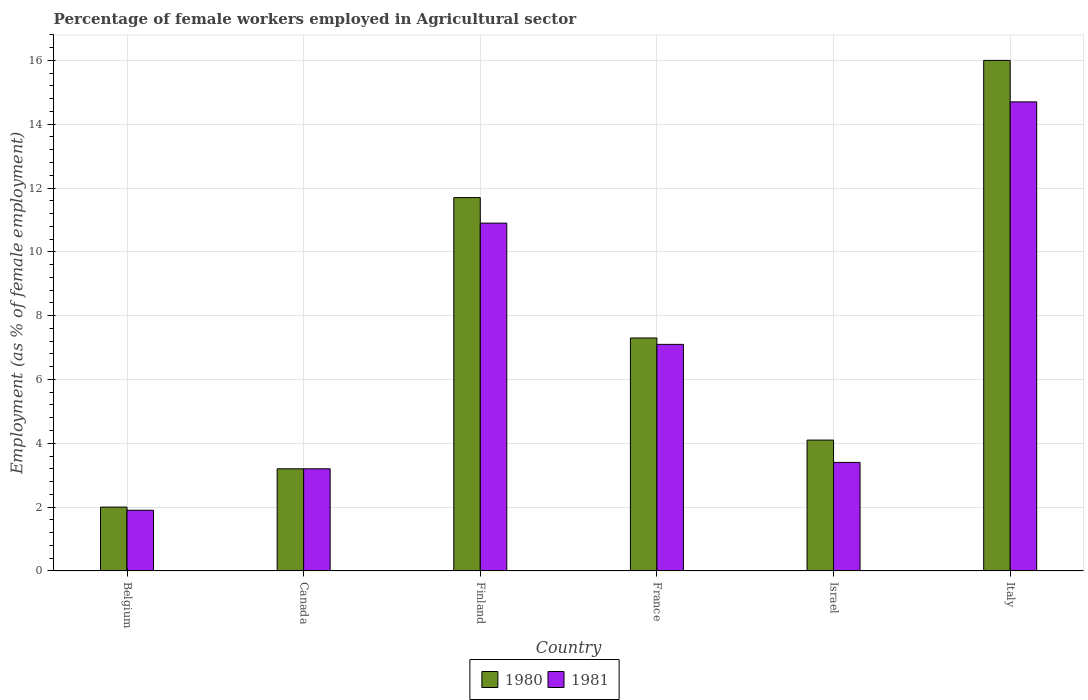How many different coloured bars are there?
Make the answer very short. 2. How many groups of bars are there?
Ensure brevity in your answer.  6. Are the number of bars on each tick of the X-axis equal?
Ensure brevity in your answer.  Yes. How many bars are there on the 4th tick from the right?
Provide a succinct answer. 2. What is the percentage of females employed in Agricultural sector in 1980 in Israel?
Make the answer very short. 4.1. Across all countries, what is the maximum percentage of females employed in Agricultural sector in 1981?
Offer a very short reply. 14.7. Across all countries, what is the minimum percentage of females employed in Agricultural sector in 1980?
Offer a terse response. 2. In which country was the percentage of females employed in Agricultural sector in 1980 minimum?
Provide a succinct answer. Belgium. What is the total percentage of females employed in Agricultural sector in 1981 in the graph?
Give a very brief answer. 41.2. What is the difference between the percentage of females employed in Agricultural sector in 1980 in Finland and that in France?
Offer a terse response. 4.4. What is the difference between the percentage of females employed in Agricultural sector in 1980 in France and the percentage of females employed in Agricultural sector in 1981 in Italy?
Provide a short and direct response. -7.4. What is the average percentage of females employed in Agricultural sector in 1981 per country?
Make the answer very short. 6.87. What is the difference between the percentage of females employed in Agricultural sector of/in 1980 and percentage of females employed in Agricultural sector of/in 1981 in Finland?
Your response must be concise. 0.8. What is the ratio of the percentage of females employed in Agricultural sector in 1980 in Canada to that in Israel?
Provide a short and direct response. 0.78. What is the difference between the highest and the second highest percentage of females employed in Agricultural sector in 1981?
Make the answer very short. -3.8. What is the difference between the highest and the lowest percentage of females employed in Agricultural sector in 1980?
Provide a succinct answer. 14. Is the sum of the percentage of females employed in Agricultural sector in 1981 in Canada and Israel greater than the maximum percentage of females employed in Agricultural sector in 1980 across all countries?
Provide a succinct answer. No. Are all the bars in the graph horizontal?
Your answer should be very brief. No. What is the difference between two consecutive major ticks on the Y-axis?
Your response must be concise. 2. Does the graph contain grids?
Offer a very short reply. Yes. How are the legend labels stacked?
Your response must be concise. Horizontal. What is the title of the graph?
Your answer should be very brief. Percentage of female workers employed in Agricultural sector. What is the label or title of the X-axis?
Provide a short and direct response. Country. What is the label or title of the Y-axis?
Give a very brief answer. Employment (as % of female employment). What is the Employment (as % of female employment) in 1980 in Belgium?
Offer a very short reply. 2. What is the Employment (as % of female employment) of 1981 in Belgium?
Keep it short and to the point. 1.9. What is the Employment (as % of female employment) in 1980 in Canada?
Make the answer very short. 3.2. What is the Employment (as % of female employment) of 1981 in Canada?
Your response must be concise. 3.2. What is the Employment (as % of female employment) in 1980 in Finland?
Offer a very short reply. 11.7. What is the Employment (as % of female employment) in 1981 in Finland?
Your answer should be compact. 10.9. What is the Employment (as % of female employment) in 1980 in France?
Your answer should be compact. 7.3. What is the Employment (as % of female employment) in 1981 in France?
Give a very brief answer. 7.1. What is the Employment (as % of female employment) in 1980 in Israel?
Ensure brevity in your answer.  4.1. What is the Employment (as % of female employment) of 1981 in Israel?
Make the answer very short. 3.4. What is the Employment (as % of female employment) in 1980 in Italy?
Your answer should be very brief. 16. What is the Employment (as % of female employment) in 1981 in Italy?
Your response must be concise. 14.7. Across all countries, what is the maximum Employment (as % of female employment) in 1980?
Offer a terse response. 16. Across all countries, what is the maximum Employment (as % of female employment) of 1981?
Keep it short and to the point. 14.7. Across all countries, what is the minimum Employment (as % of female employment) of 1980?
Keep it short and to the point. 2. Across all countries, what is the minimum Employment (as % of female employment) in 1981?
Give a very brief answer. 1.9. What is the total Employment (as % of female employment) in 1980 in the graph?
Offer a very short reply. 44.3. What is the total Employment (as % of female employment) of 1981 in the graph?
Offer a terse response. 41.2. What is the difference between the Employment (as % of female employment) of 1981 in Belgium and that in Canada?
Keep it short and to the point. -1.3. What is the difference between the Employment (as % of female employment) of 1981 in Belgium and that in Finland?
Keep it short and to the point. -9. What is the difference between the Employment (as % of female employment) in 1980 in Belgium and that in Israel?
Your answer should be very brief. -2.1. What is the difference between the Employment (as % of female employment) of 1981 in Belgium and that in Italy?
Offer a terse response. -12.8. What is the difference between the Employment (as % of female employment) of 1980 in Canada and that in Finland?
Your answer should be very brief. -8.5. What is the difference between the Employment (as % of female employment) of 1980 in Canada and that in France?
Keep it short and to the point. -4.1. What is the difference between the Employment (as % of female employment) of 1981 in Canada and that in France?
Make the answer very short. -3.9. What is the difference between the Employment (as % of female employment) of 1980 in Canada and that in Israel?
Give a very brief answer. -0.9. What is the difference between the Employment (as % of female employment) in 1980 in Canada and that in Italy?
Ensure brevity in your answer.  -12.8. What is the difference between the Employment (as % of female employment) of 1981 in Canada and that in Italy?
Offer a terse response. -11.5. What is the difference between the Employment (as % of female employment) in 1980 in Finland and that in France?
Your answer should be compact. 4.4. What is the difference between the Employment (as % of female employment) of 1981 in Finland and that in France?
Offer a terse response. 3.8. What is the difference between the Employment (as % of female employment) in 1981 in Finland and that in Israel?
Keep it short and to the point. 7.5. What is the difference between the Employment (as % of female employment) of 1980 in Finland and that in Italy?
Your answer should be compact. -4.3. What is the difference between the Employment (as % of female employment) in 1980 in France and that in Israel?
Offer a terse response. 3.2. What is the difference between the Employment (as % of female employment) in 1981 in France and that in Italy?
Give a very brief answer. -7.6. What is the difference between the Employment (as % of female employment) in 1980 in Israel and that in Italy?
Ensure brevity in your answer.  -11.9. What is the difference between the Employment (as % of female employment) in 1981 in Israel and that in Italy?
Give a very brief answer. -11.3. What is the difference between the Employment (as % of female employment) of 1980 in Belgium and the Employment (as % of female employment) of 1981 in Canada?
Make the answer very short. -1.2. What is the difference between the Employment (as % of female employment) of 1980 in Belgium and the Employment (as % of female employment) of 1981 in Finland?
Keep it short and to the point. -8.9. What is the difference between the Employment (as % of female employment) of 1980 in Canada and the Employment (as % of female employment) of 1981 in Finland?
Offer a terse response. -7.7. What is the difference between the Employment (as % of female employment) in 1980 in Finland and the Employment (as % of female employment) in 1981 in France?
Offer a very short reply. 4.6. What is the difference between the Employment (as % of female employment) in 1980 in Finland and the Employment (as % of female employment) in 1981 in Israel?
Give a very brief answer. 8.3. What is the difference between the Employment (as % of female employment) in 1980 in Israel and the Employment (as % of female employment) in 1981 in Italy?
Keep it short and to the point. -10.6. What is the average Employment (as % of female employment) of 1980 per country?
Ensure brevity in your answer.  7.38. What is the average Employment (as % of female employment) in 1981 per country?
Ensure brevity in your answer.  6.87. What is the difference between the Employment (as % of female employment) of 1980 and Employment (as % of female employment) of 1981 in Belgium?
Provide a succinct answer. 0.1. What is the difference between the Employment (as % of female employment) of 1980 and Employment (as % of female employment) of 1981 in Canada?
Your answer should be very brief. 0. What is the difference between the Employment (as % of female employment) of 1980 and Employment (as % of female employment) of 1981 in Finland?
Provide a succinct answer. 0.8. What is the difference between the Employment (as % of female employment) in 1980 and Employment (as % of female employment) in 1981 in France?
Offer a very short reply. 0.2. What is the difference between the Employment (as % of female employment) of 1980 and Employment (as % of female employment) of 1981 in Italy?
Make the answer very short. 1.3. What is the ratio of the Employment (as % of female employment) of 1980 in Belgium to that in Canada?
Offer a terse response. 0.62. What is the ratio of the Employment (as % of female employment) in 1981 in Belgium to that in Canada?
Offer a very short reply. 0.59. What is the ratio of the Employment (as % of female employment) in 1980 in Belgium to that in Finland?
Your response must be concise. 0.17. What is the ratio of the Employment (as % of female employment) of 1981 in Belgium to that in Finland?
Your response must be concise. 0.17. What is the ratio of the Employment (as % of female employment) of 1980 in Belgium to that in France?
Offer a terse response. 0.27. What is the ratio of the Employment (as % of female employment) of 1981 in Belgium to that in France?
Keep it short and to the point. 0.27. What is the ratio of the Employment (as % of female employment) of 1980 in Belgium to that in Israel?
Ensure brevity in your answer.  0.49. What is the ratio of the Employment (as % of female employment) in 1981 in Belgium to that in Israel?
Provide a succinct answer. 0.56. What is the ratio of the Employment (as % of female employment) in 1980 in Belgium to that in Italy?
Provide a succinct answer. 0.12. What is the ratio of the Employment (as % of female employment) in 1981 in Belgium to that in Italy?
Ensure brevity in your answer.  0.13. What is the ratio of the Employment (as % of female employment) of 1980 in Canada to that in Finland?
Make the answer very short. 0.27. What is the ratio of the Employment (as % of female employment) of 1981 in Canada to that in Finland?
Keep it short and to the point. 0.29. What is the ratio of the Employment (as % of female employment) of 1980 in Canada to that in France?
Offer a very short reply. 0.44. What is the ratio of the Employment (as % of female employment) in 1981 in Canada to that in France?
Provide a short and direct response. 0.45. What is the ratio of the Employment (as % of female employment) of 1980 in Canada to that in Israel?
Make the answer very short. 0.78. What is the ratio of the Employment (as % of female employment) in 1981 in Canada to that in Italy?
Your answer should be compact. 0.22. What is the ratio of the Employment (as % of female employment) in 1980 in Finland to that in France?
Offer a terse response. 1.6. What is the ratio of the Employment (as % of female employment) in 1981 in Finland to that in France?
Your answer should be very brief. 1.54. What is the ratio of the Employment (as % of female employment) of 1980 in Finland to that in Israel?
Ensure brevity in your answer.  2.85. What is the ratio of the Employment (as % of female employment) of 1981 in Finland to that in Israel?
Your answer should be compact. 3.21. What is the ratio of the Employment (as % of female employment) of 1980 in Finland to that in Italy?
Provide a short and direct response. 0.73. What is the ratio of the Employment (as % of female employment) of 1981 in Finland to that in Italy?
Make the answer very short. 0.74. What is the ratio of the Employment (as % of female employment) of 1980 in France to that in Israel?
Offer a terse response. 1.78. What is the ratio of the Employment (as % of female employment) of 1981 in France to that in Israel?
Provide a succinct answer. 2.09. What is the ratio of the Employment (as % of female employment) of 1980 in France to that in Italy?
Make the answer very short. 0.46. What is the ratio of the Employment (as % of female employment) of 1981 in France to that in Italy?
Your response must be concise. 0.48. What is the ratio of the Employment (as % of female employment) in 1980 in Israel to that in Italy?
Your answer should be very brief. 0.26. What is the ratio of the Employment (as % of female employment) of 1981 in Israel to that in Italy?
Offer a terse response. 0.23. What is the difference between the highest and the second highest Employment (as % of female employment) in 1980?
Your response must be concise. 4.3. What is the difference between the highest and the second highest Employment (as % of female employment) in 1981?
Your response must be concise. 3.8. 